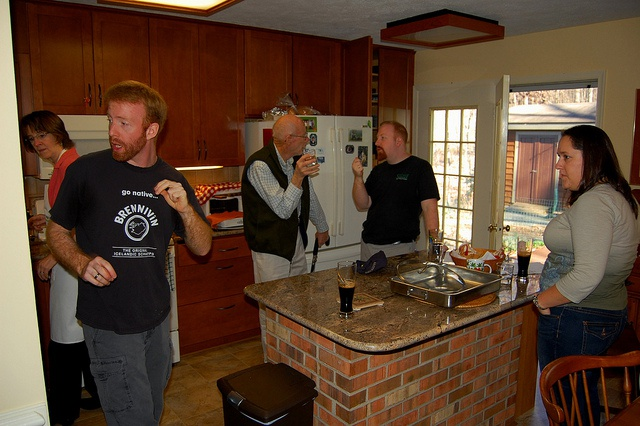Describe the objects in this image and their specific colors. I can see people in tan, black, maroon, and brown tones, people in tan, black, and gray tones, dining table in tan, maroon, black, and gray tones, people in tan, black, gray, and maroon tones, and people in tan, black, gray, maroon, and brown tones in this image. 